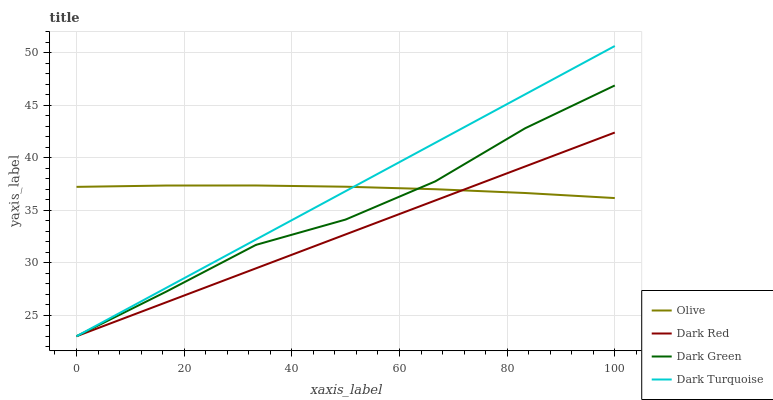Does Dark Red have the minimum area under the curve?
Answer yes or no. Yes. Does Olive have the maximum area under the curve?
Answer yes or no. Yes. Does Dark Turquoise have the minimum area under the curve?
Answer yes or no. No. Does Dark Turquoise have the maximum area under the curve?
Answer yes or no. No. Is Dark Turquoise the smoothest?
Answer yes or no. Yes. Is Dark Green the roughest?
Answer yes or no. Yes. Is Dark Red the smoothest?
Answer yes or no. No. Is Dark Red the roughest?
Answer yes or no. No. Does Dark Red have the lowest value?
Answer yes or no. Yes. Does Dark Turquoise have the highest value?
Answer yes or no. Yes. Does Dark Red have the highest value?
Answer yes or no. No. Does Olive intersect Dark Turquoise?
Answer yes or no. Yes. Is Olive less than Dark Turquoise?
Answer yes or no. No. Is Olive greater than Dark Turquoise?
Answer yes or no. No. 